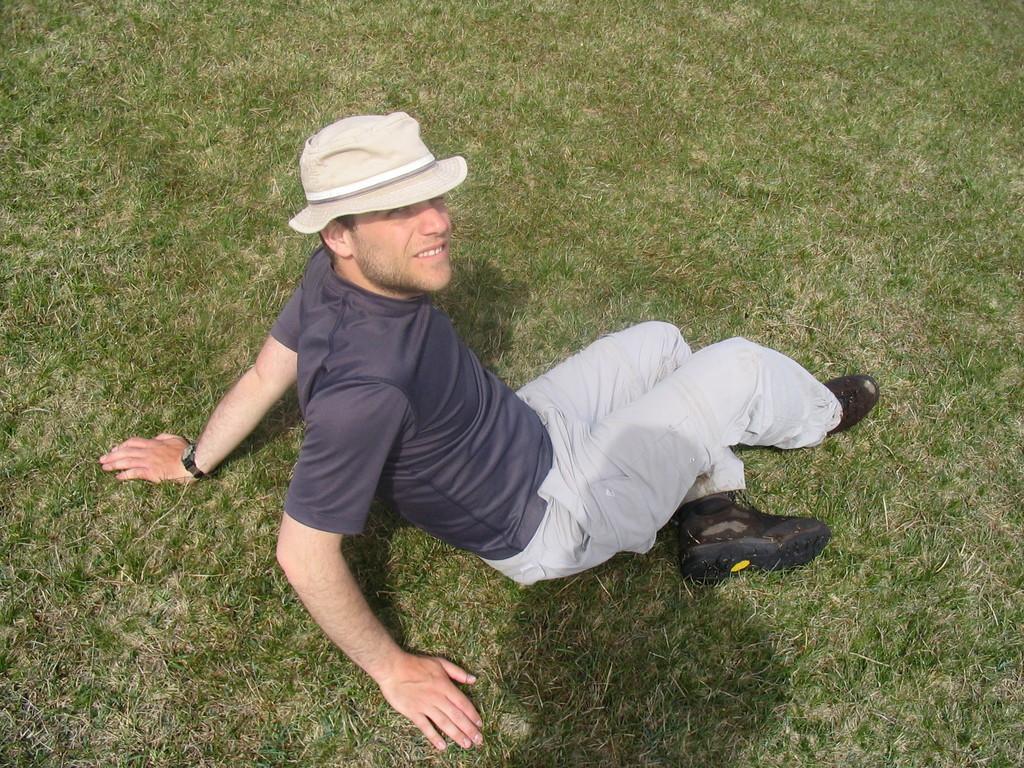Describe this image in one or two sentences. In this picture I can see a man sitting on the grass. 